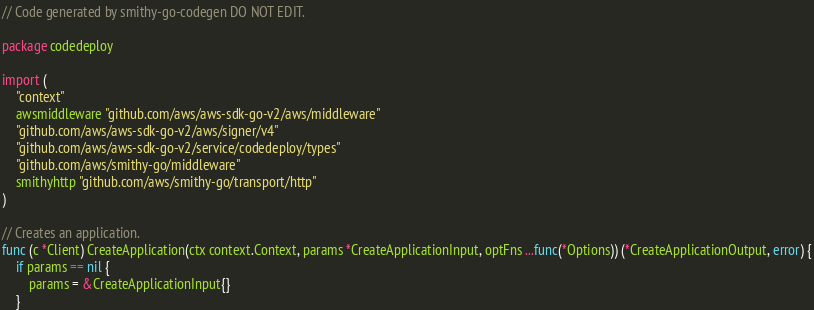Convert code to text. <code><loc_0><loc_0><loc_500><loc_500><_Go_>// Code generated by smithy-go-codegen DO NOT EDIT.

package codedeploy

import (
	"context"
	awsmiddleware "github.com/aws/aws-sdk-go-v2/aws/middleware"
	"github.com/aws/aws-sdk-go-v2/aws/signer/v4"
	"github.com/aws/aws-sdk-go-v2/service/codedeploy/types"
	"github.com/aws/smithy-go/middleware"
	smithyhttp "github.com/aws/smithy-go/transport/http"
)

// Creates an application.
func (c *Client) CreateApplication(ctx context.Context, params *CreateApplicationInput, optFns ...func(*Options)) (*CreateApplicationOutput, error) {
	if params == nil {
		params = &CreateApplicationInput{}
	}
</code> 